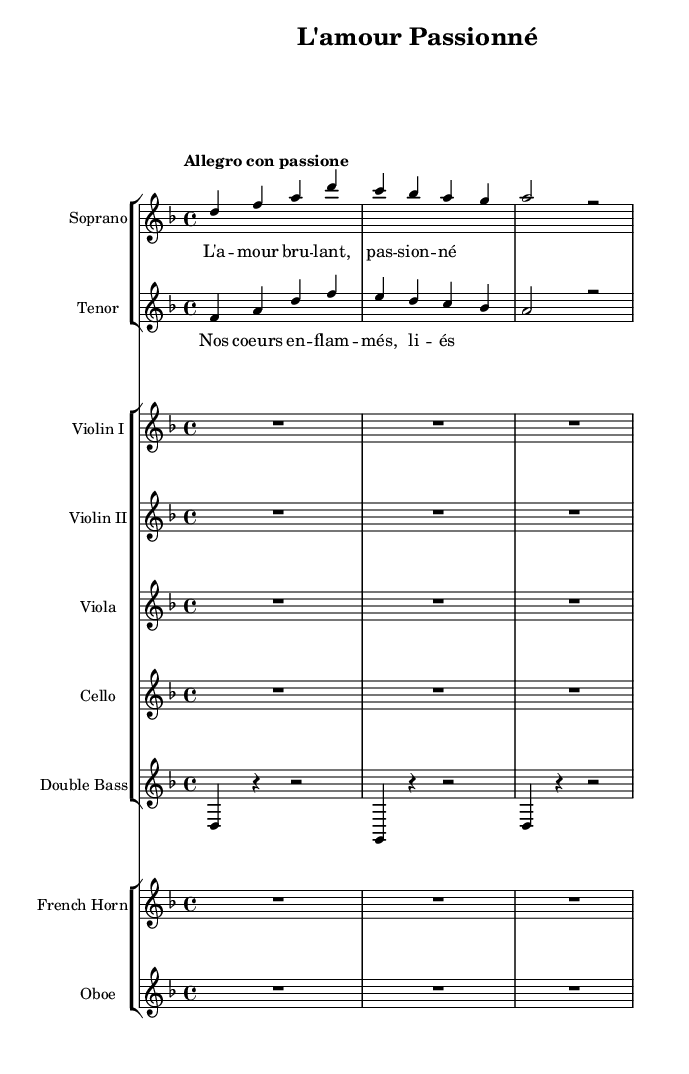What is the key signature of this music? The key signature displayed at the beginning of the sheet music shows two flats, indicating that the piece is in D minor.
Answer: D minor What is the time signature of this music? The time signature is found at the beginning and is indicated as 4/4, which means there are four beats in each measure and a quarter note receives one beat.
Answer: 4/4 What is the tempo marking for this piece? The tempo marking at the beginning states "Allegro con passione," which indicates a lively and passionate tempo.
Answer: Allegro con passione How many voices are used in this piece? The piece contains two distinctly notated voices: Soprano and Tenor, as indicated by their respective staffs.
Answer: Two What musical instruments are used in the accompaniment? The accompaniment consists of strings and woodwinds, specified as Violin I, Violin II, Viola, Cello, Double Bass, French Horn, and Oboe.
Answer: Strings and woodwinds In which language are the lyrics sung? The lyrics for the Soprano and Tenor are written in French, as evident from the words used in their respective lyric sections.
Answer: French What is the dramatic theme of the lyrics? The lyrics reference themes of passionate love and flames, indicative of the tempestuous romantic relationships characteristic of dramatic opera.
Answer: Passionate love 